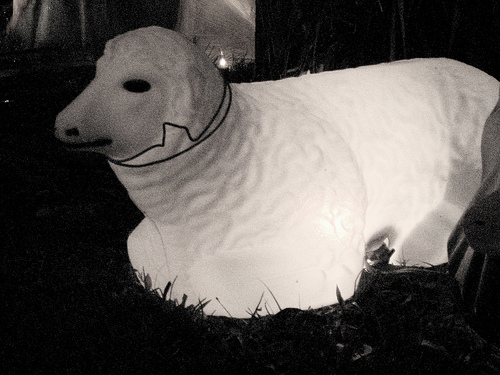<image>
Is there a fake sheep behind the ground? Yes. From this viewpoint, the fake sheep is positioned behind the ground, with the ground partially or fully occluding the fake sheep. 